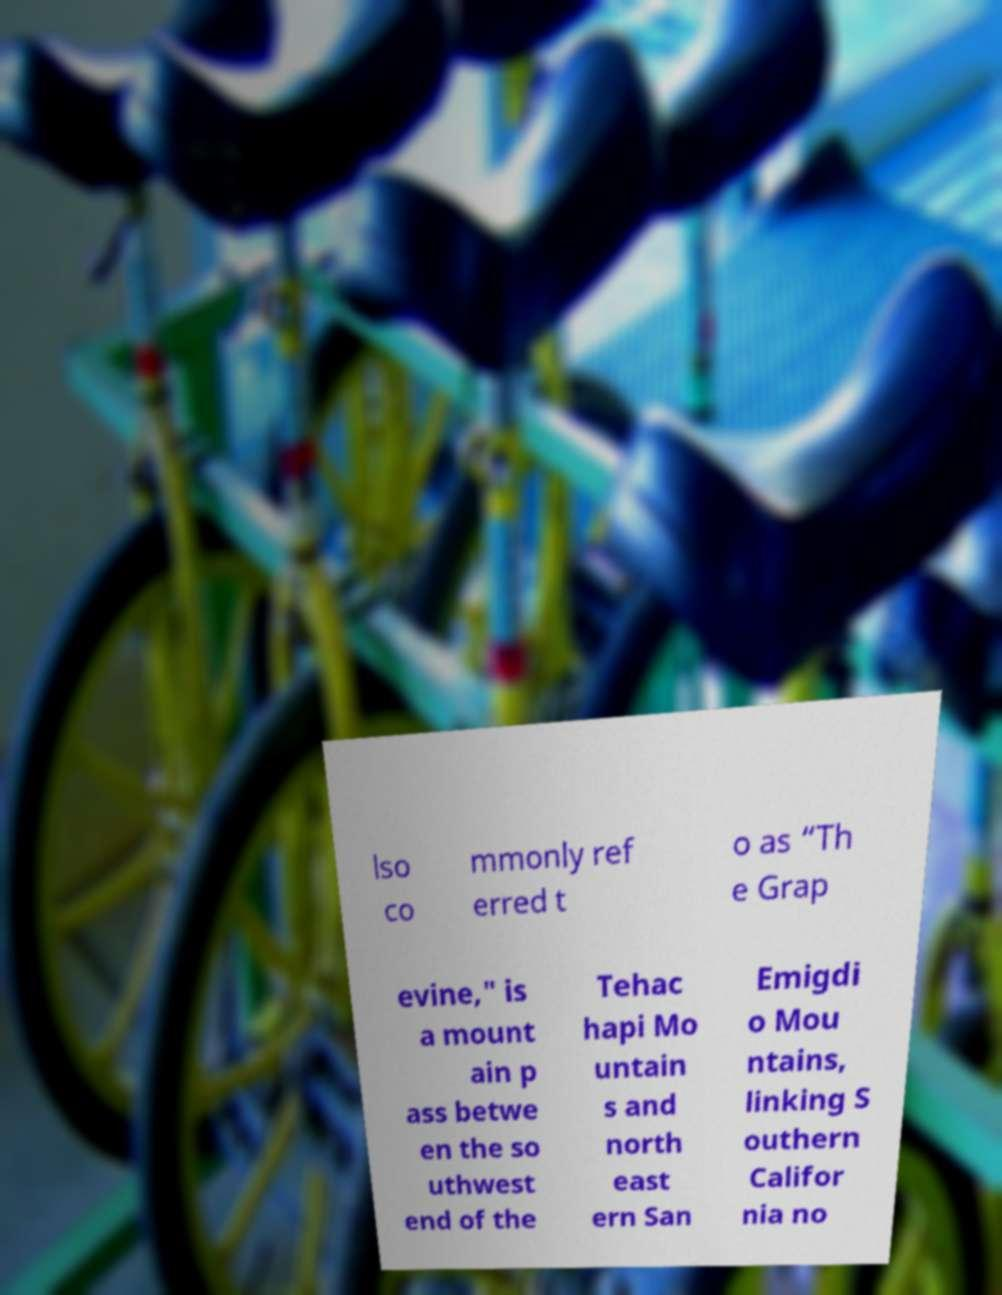What messages or text are displayed in this image? I need them in a readable, typed format. lso co mmonly ref erred t o as “Th e Grap evine," is a mount ain p ass betwe en the so uthwest end of the Tehac hapi Mo untain s and north east ern San Emigdi o Mou ntains, linking S outhern Califor nia no 